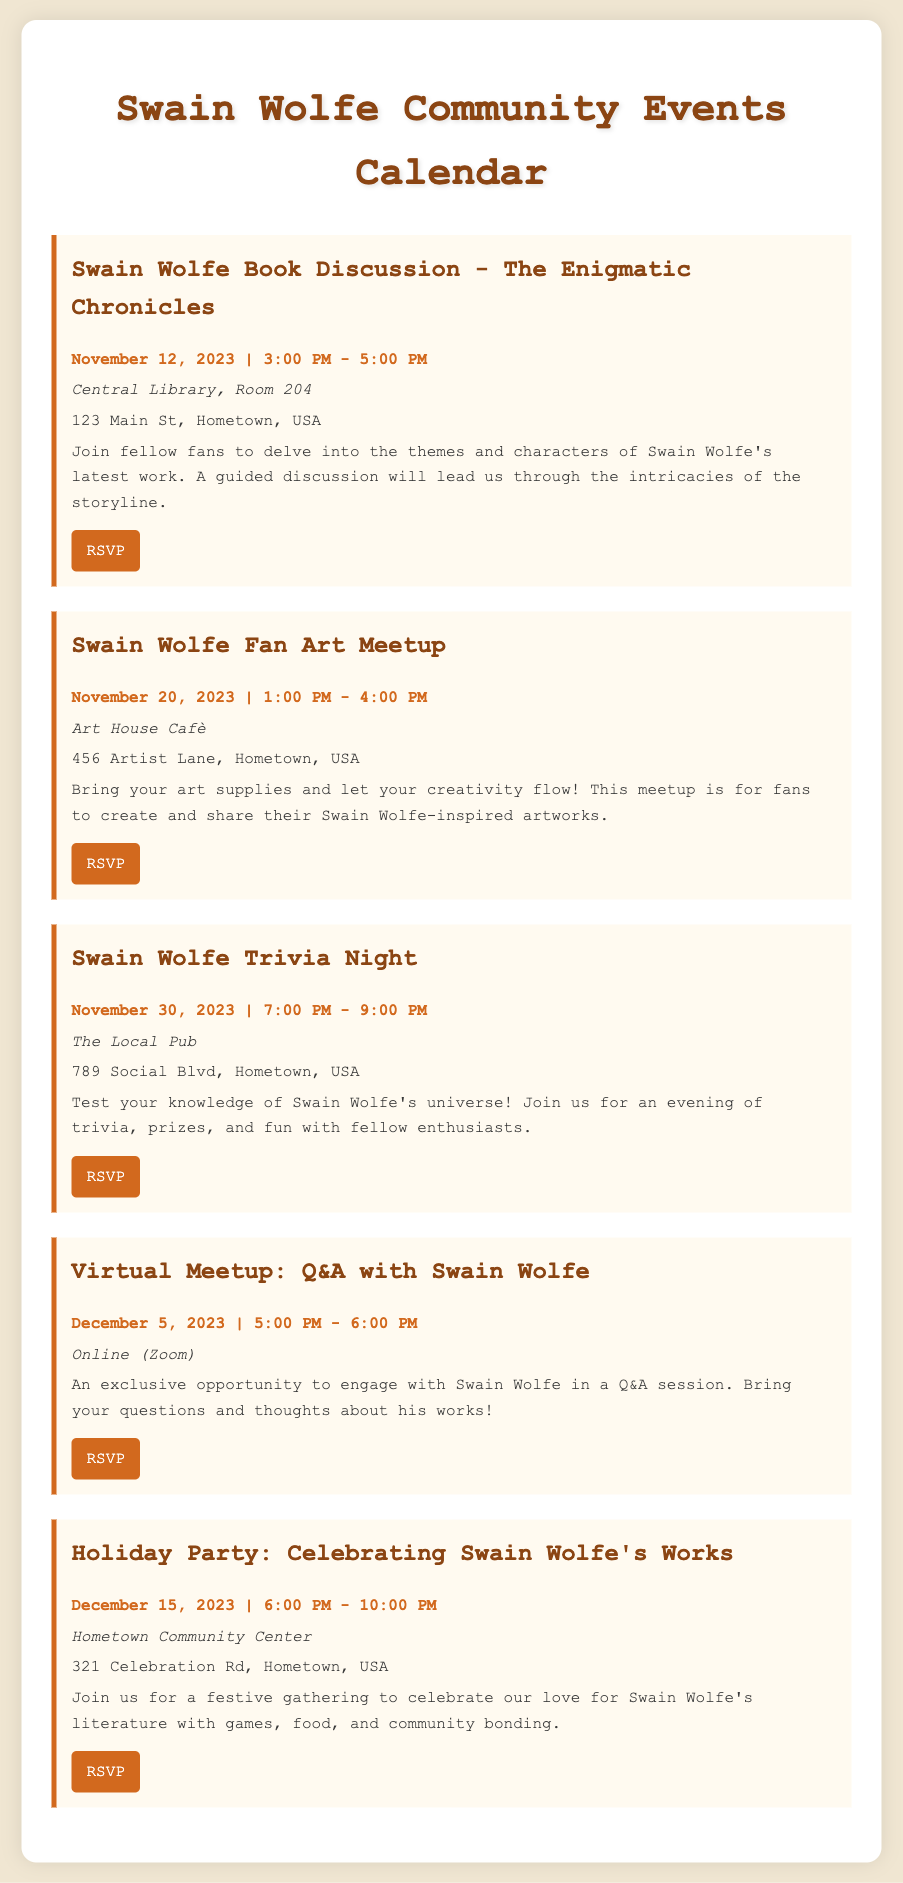what is the date of the Swain Wolfe Book Discussion? The date is listed in the event details of the document as November 12, 2023.
Answer: November 12, 2023 where is the Swain Wolfe Fan Art Meetup taking place? The location is provided in the event details, which shows Art House Cafè.
Answer: Art House Cafè what time does the Trivia Night start? The start time for Trivia Night is indicated in the document as 7:00 PM.
Answer: 7:00 PM how long is the Virtual Meetup: Q&A with Swain Wolfe? The duration can be inferred from the given start and end times, which is 1 hour.
Answer: 1 hour what type of event is scheduled for December 15, 2023? The event is described in the document as a Holiday Party to celebrate Swain Wolfe's works.
Answer: Holiday Party how many events are listed in the document? The total number of events is determined by counting the individual event entries, which totals five.
Answer: five what venue will host the Swain Wolfe Book Discussion? The document specifies Central Library, Room 204 as the venue for this discussion.
Answer: Central Library, Room 204 what is the RSVP link for the Trivia Night? The RSVP link is provided in the document as a hyperlink associated with the Trivia Night event title.
Answer: https://example.com/rsvp-trivia-night what is the theme of the Fan Art Meetup? The theme is implied in the description, where it focuses on creating and sharing Swain Wolfe-inspired artworks.
Answer: Swain Wolfe-inspired artworks 